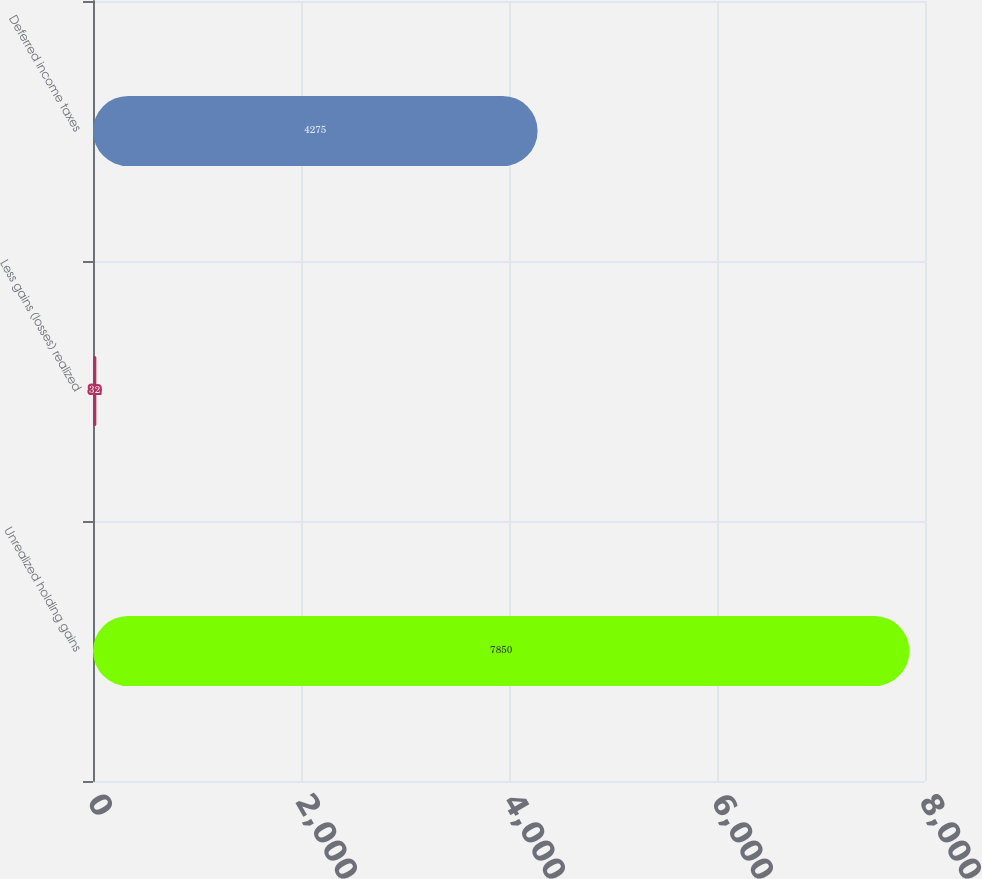Convert chart to OTSL. <chart><loc_0><loc_0><loc_500><loc_500><bar_chart><fcel>Unrealized holding gains<fcel>Less gains (losses) realized<fcel>Deferred income taxes<nl><fcel>7850<fcel>32<fcel>4275<nl></chart> 